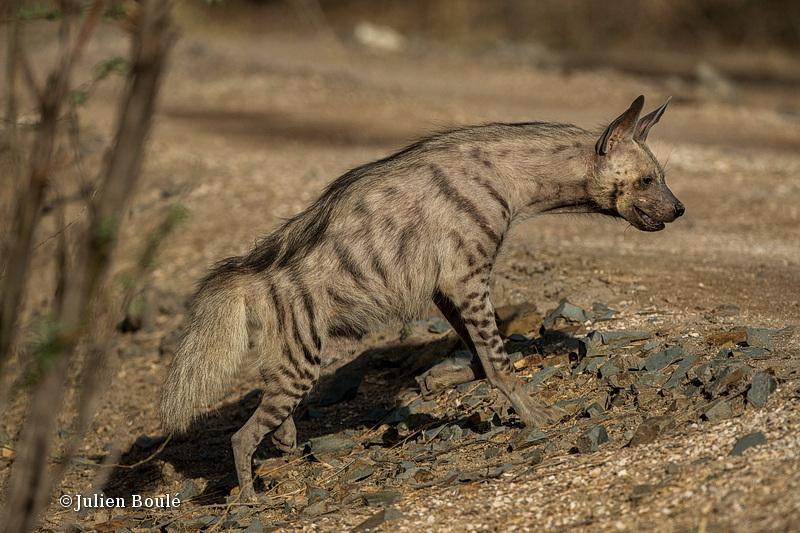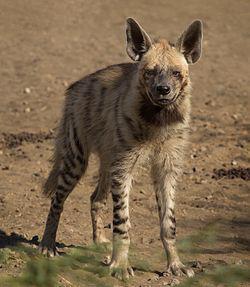The first image is the image on the left, the second image is the image on the right. Assess this claim about the two images: "The animal in the image on the left is facing the camera". Correct or not? Answer yes or no. No. 